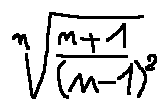<formula> <loc_0><loc_0><loc_500><loc_500>\sqrt { [ } n ] { \frac { n + 1 } { ( n - 1 ) ^ { 2 } } }</formula> 